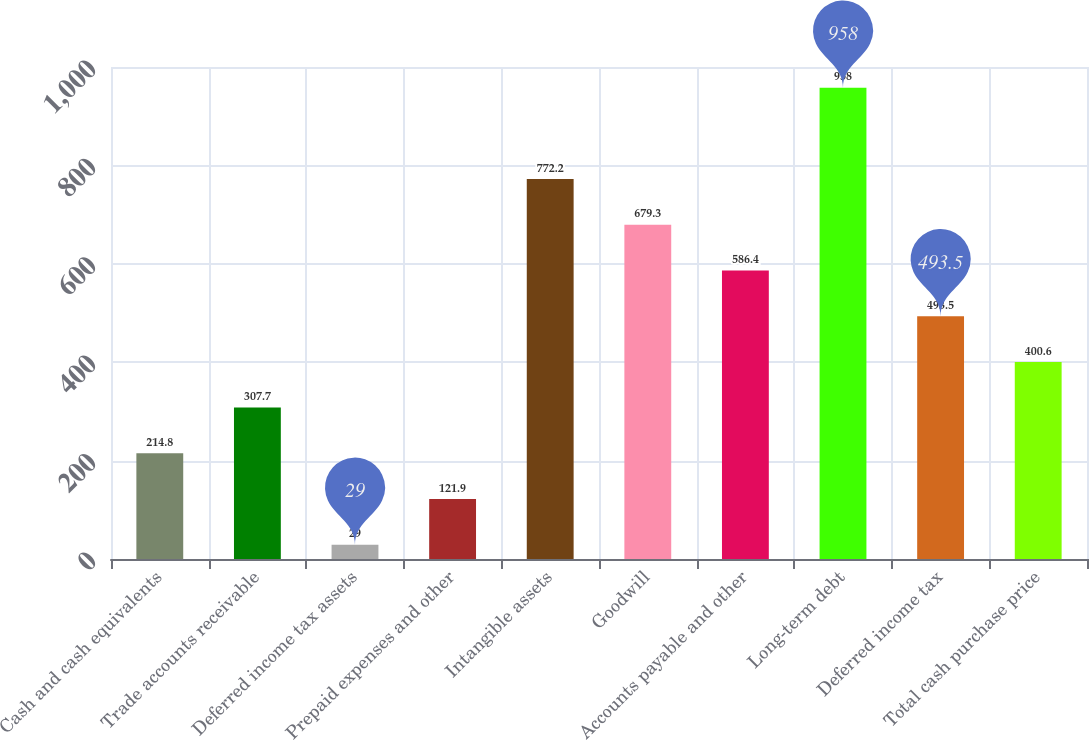<chart> <loc_0><loc_0><loc_500><loc_500><bar_chart><fcel>Cash and cash equivalents<fcel>Trade accounts receivable<fcel>Deferred income tax assets<fcel>Prepaid expenses and other<fcel>Intangible assets<fcel>Goodwill<fcel>Accounts payable and other<fcel>Long-term debt<fcel>Deferred income tax<fcel>Total cash purchase price<nl><fcel>214.8<fcel>307.7<fcel>29<fcel>121.9<fcel>772.2<fcel>679.3<fcel>586.4<fcel>958<fcel>493.5<fcel>400.6<nl></chart> 